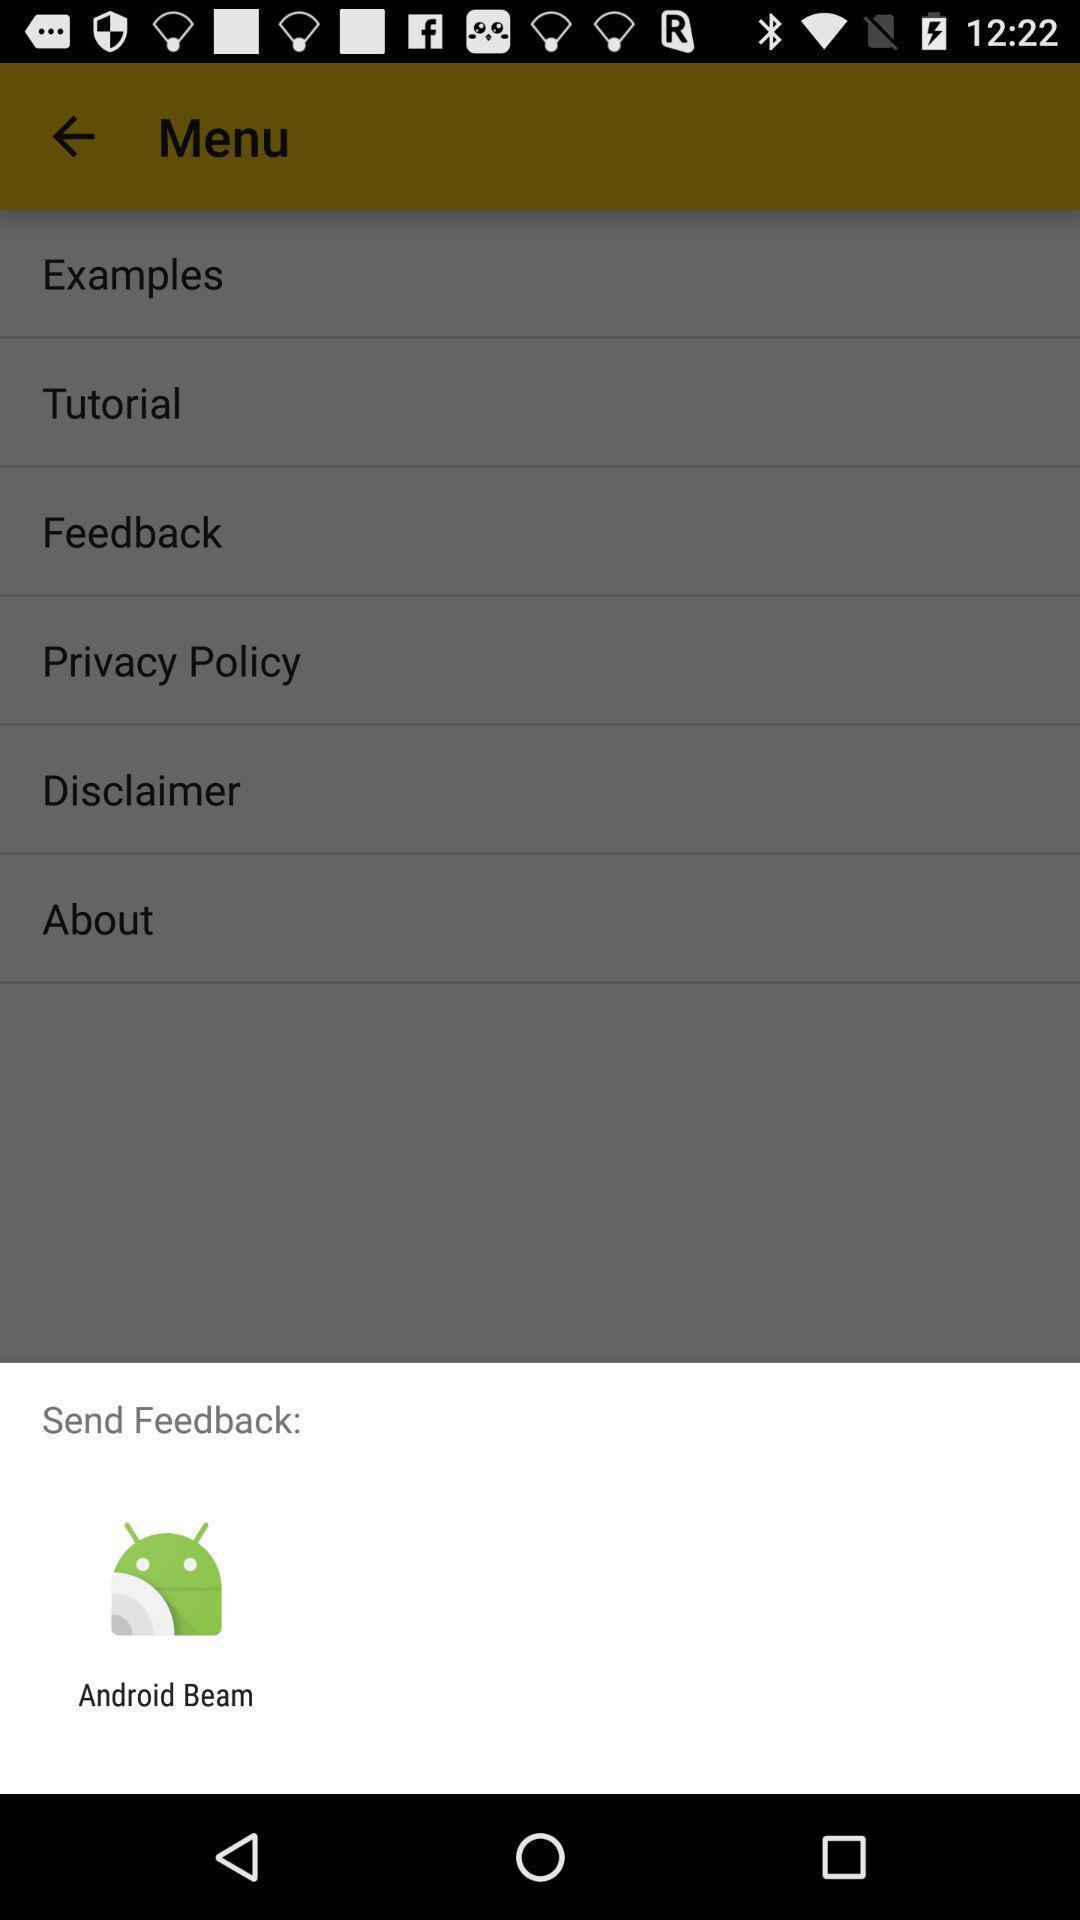Tell me what you see in this picture. Pop-up showing to send feedback. 